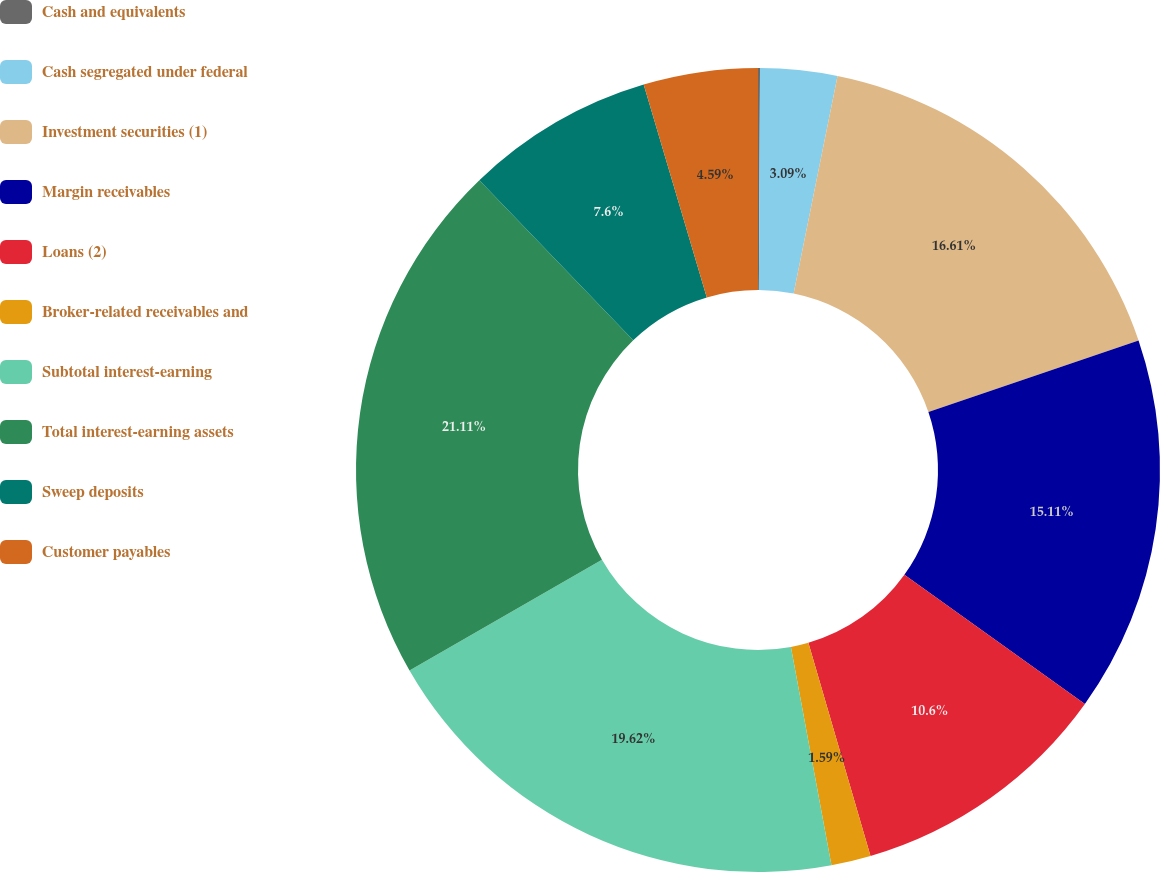<chart> <loc_0><loc_0><loc_500><loc_500><pie_chart><fcel>Cash and equivalents<fcel>Cash segregated under federal<fcel>Investment securities (1)<fcel>Margin receivables<fcel>Loans (2)<fcel>Broker-related receivables and<fcel>Subtotal interest-earning<fcel>Total interest-earning assets<fcel>Sweep deposits<fcel>Customer payables<nl><fcel>0.08%<fcel>3.09%<fcel>16.61%<fcel>15.11%<fcel>10.6%<fcel>1.59%<fcel>19.62%<fcel>21.12%<fcel>7.6%<fcel>4.59%<nl></chart> 